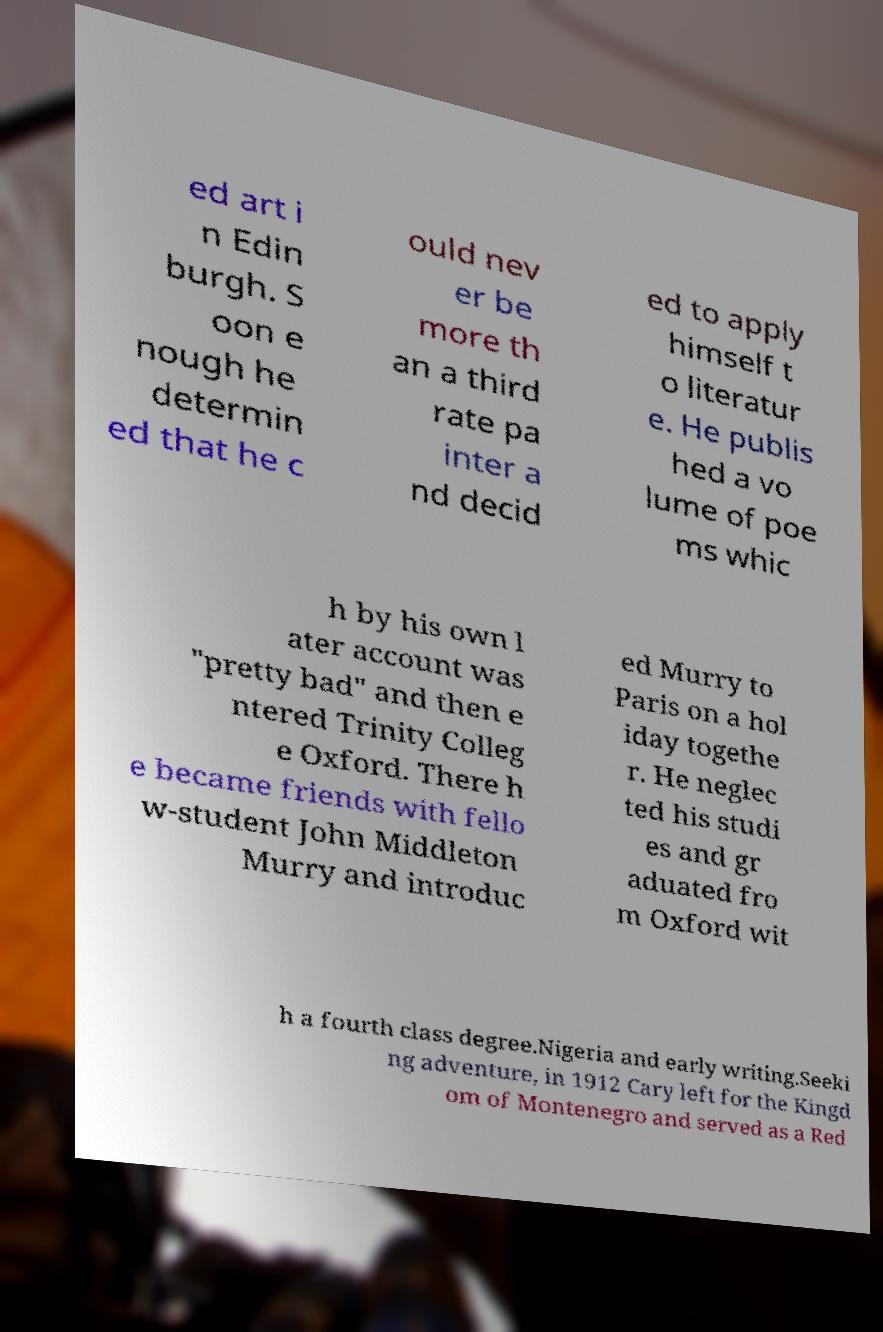Can you read and provide the text displayed in the image?This photo seems to have some interesting text. Can you extract and type it out for me? ed art i n Edin burgh. S oon e nough he determin ed that he c ould nev er be more th an a third rate pa inter a nd decid ed to apply himself t o literatur e. He publis hed a vo lume of poe ms whic h by his own l ater account was "pretty bad" and then e ntered Trinity Colleg e Oxford. There h e became friends with fello w-student John Middleton Murry and introduc ed Murry to Paris on a hol iday togethe r. He neglec ted his studi es and gr aduated fro m Oxford wit h a fourth class degree.Nigeria and early writing.Seeki ng adventure, in 1912 Cary left for the Kingd om of Montenegro and served as a Red 